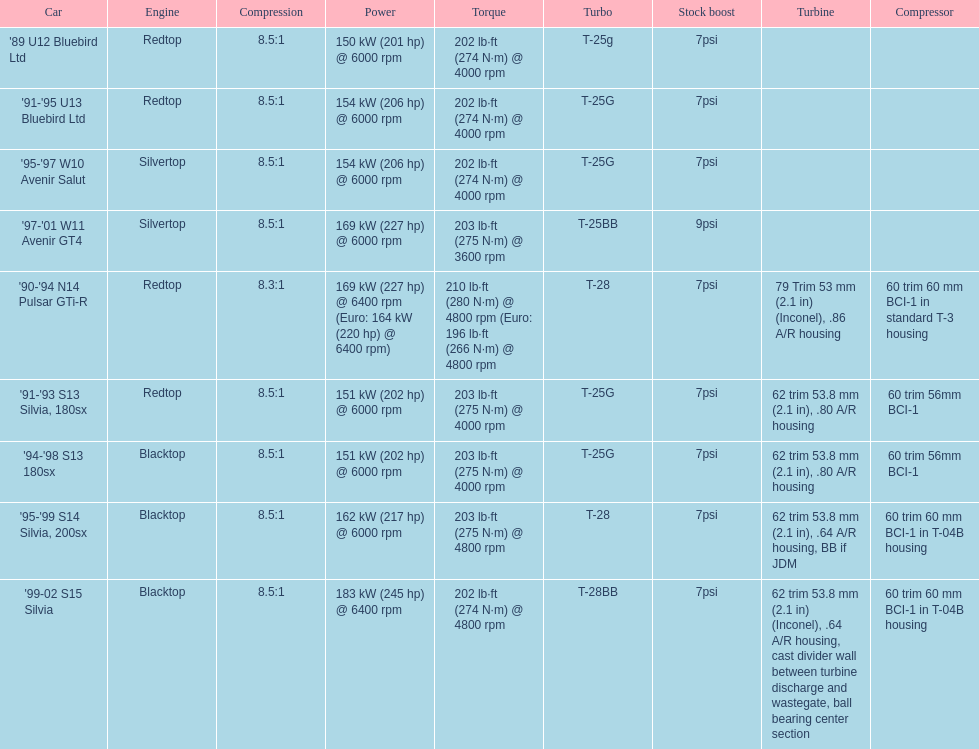I'm looking to parse the entire table for insights. Could you assist me with that? {'header': ['Car', 'Engine', 'Compression', 'Power', 'Torque', 'Turbo', 'Stock boost', 'Turbine', 'Compressor'], 'rows': [["'89 U12 Bluebird Ltd", 'Redtop', '8.5:1', '150\xa0kW (201\xa0hp) @ 6000 rpm', '202\xa0lb·ft (274\xa0N·m) @ 4000 rpm', 'T-25g', '7psi', '', ''], ["'91-'95 U13 Bluebird Ltd", 'Redtop', '8.5:1', '154\xa0kW (206\xa0hp) @ 6000 rpm', '202\xa0lb·ft (274\xa0N·m) @ 4000 rpm', 'T-25G', '7psi', '', ''], ["'95-'97 W10 Avenir Salut", 'Silvertop', '8.5:1', '154\xa0kW (206\xa0hp) @ 6000 rpm', '202\xa0lb·ft (274\xa0N·m) @ 4000 rpm', 'T-25G', '7psi', '', ''], ["'97-'01 W11 Avenir GT4", 'Silvertop', '8.5:1', '169\xa0kW (227\xa0hp) @ 6000 rpm', '203\xa0lb·ft (275\xa0N·m) @ 3600 rpm', 'T-25BB', '9psi', '', ''], ["'90-'94 N14 Pulsar GTi-R", 'Redtop', '8.3:1', '169\xa0kW (227\xa0hp) @ 6400 rpm (Euro: 164\xa0kW (220\xa0hp) @ 6400 rpm)', '210\xa0lb·ft (280\xa0N·m) @ 4800 rpm (Euro: 196\xa0lb·ft (266\xa0N·m) @ 4800 rpm', 'T-28', '7psi', '79 Trim 53\xa0mm (2.1\xa0in) (Inconel), .86 A/R housing', '60 trim 60\xa0mm BCI-1 in standard T-3 housing'], ["'91-'93 S13 Silvia, 180sx", 'Redtop', '8.5:1', '151\xa0kW (202\xa0hp) @ 6000 rpm', '203\xa0lb·ft (275\xa0N·m) @ 4000 rpm', 'T-25G', '7psi', '62 trim 53.8\xa0mm (2.1\xa0in), .80 A/R housing', '60 trim 56mm BCI-1'], ["'94-'98 S13 180sx", 'Blacktop', '8.5:1', '151\xa0kW (202\xa0hp) @ 6000 rpm', '203\xa0lb·ft (275\xa0N·m) @ 4000 rpm', 'T-25G', '7psi', '62 trim 53.8\xa0mm (2.1\xa0in), .80 A/R housing', '60 trim 56mm BCI-1'], ["'95-'99 S14 Silvia, 200sx", 'Blacktop', '8.5:1', '162\xa0kW (217\xa0hp) @ 6000 rpm', '203\xa0lb·ft (275\xa0N·m) @ 4800 rpm', 'T-28', '7psi', '62 trim 53.8\xa0mm (2.1\xa0in), .64 A/R housing, BB if JDM', '60 trim 60\xa0mm BCI-1 in T-04B housing'], ["'99-02 S15 Silvia", 'Blacktop', '8.5:1', '183\xa0kW (245\xa0hp) @ 6400 rpm', '202\xa0lb·ft (274\xa0N·m) @ 4800 rpm', 'T-28BB', '7psi', '62 trim 53.8\xa0mm (2.1\xa0in) (Inconel), .64 A/R housing, cast divider wall between turbine discharge and wastegate, ball bearing center section', '60 trim 60\xa0mm BCI-1 in T-04B housing']]} What is the compression ratio for the 90-94 n14 pulsar gti-r model? 8.3:1. 